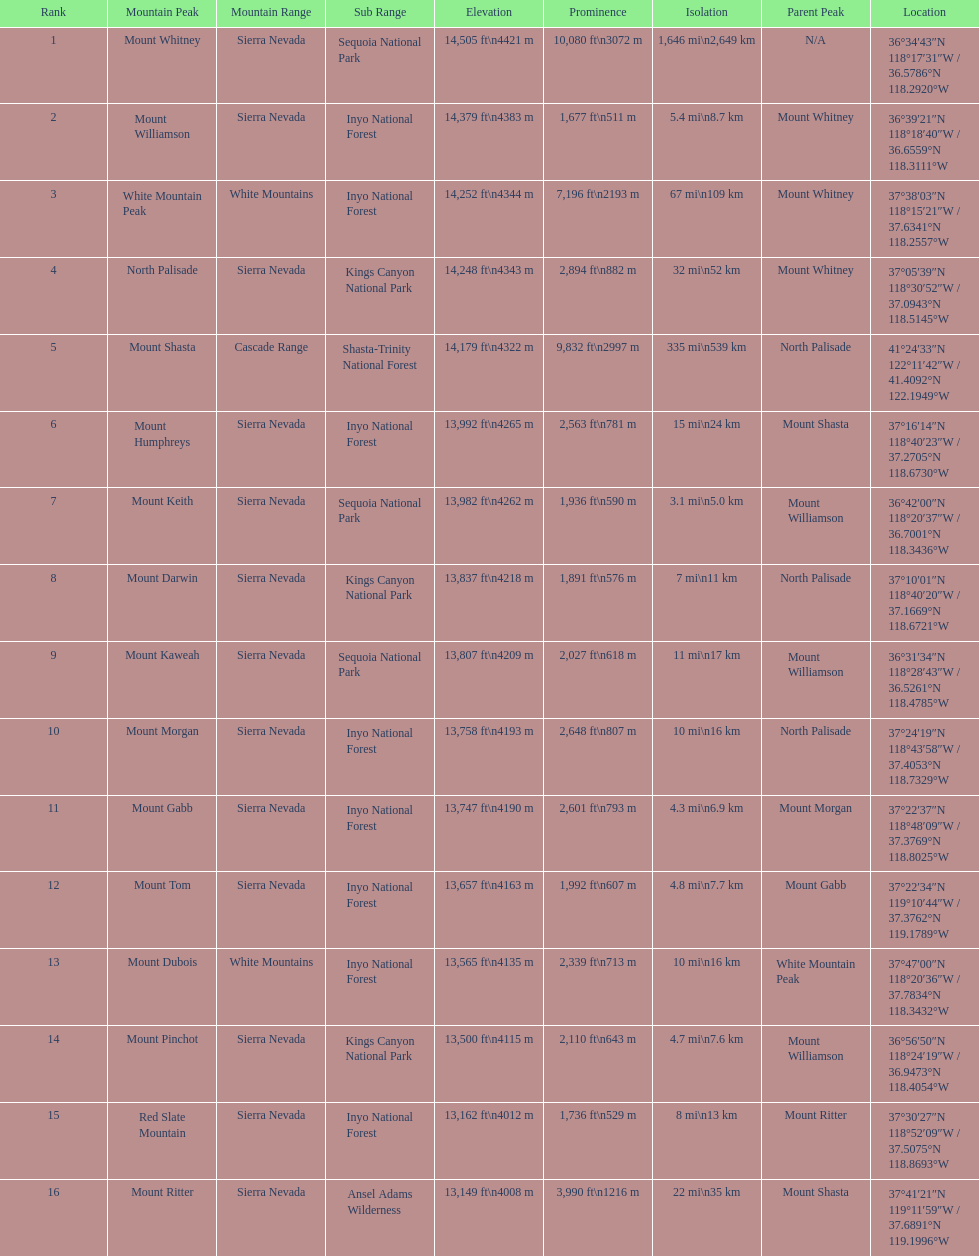What is the total elevation (in ft) of mount whitney? 14,505 ft. 